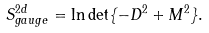Convert formula to latex. <formula><loc_0><loc_0><loc_500><loc_500>S ^ { 2 d } _ { g a u g e } = \ln \det \{ - D ^ { 2 } + M ^ { 2 } \} .</formula> 